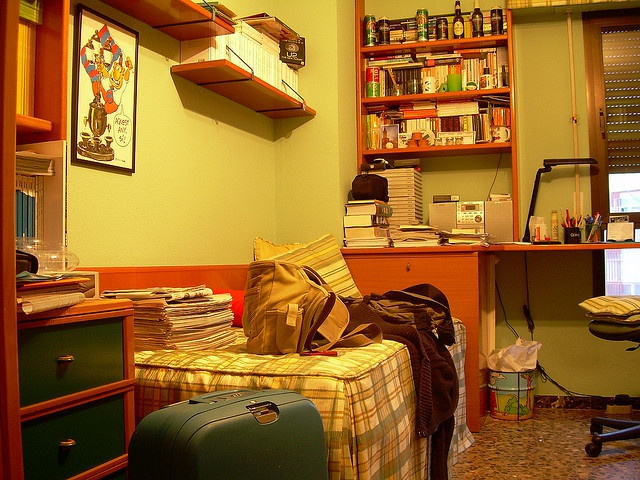Describe the objects in this image and their specific colors. I can see book in maroon, brown, orange, and red tones, bed in maroon, olive, orange, red, and gold tones, suitcase in maroon, black, darkgreen, and olive tones, handbag in maroon, brown, and orange tones, and backpack in maroon, brown, and orange tones in this image. 